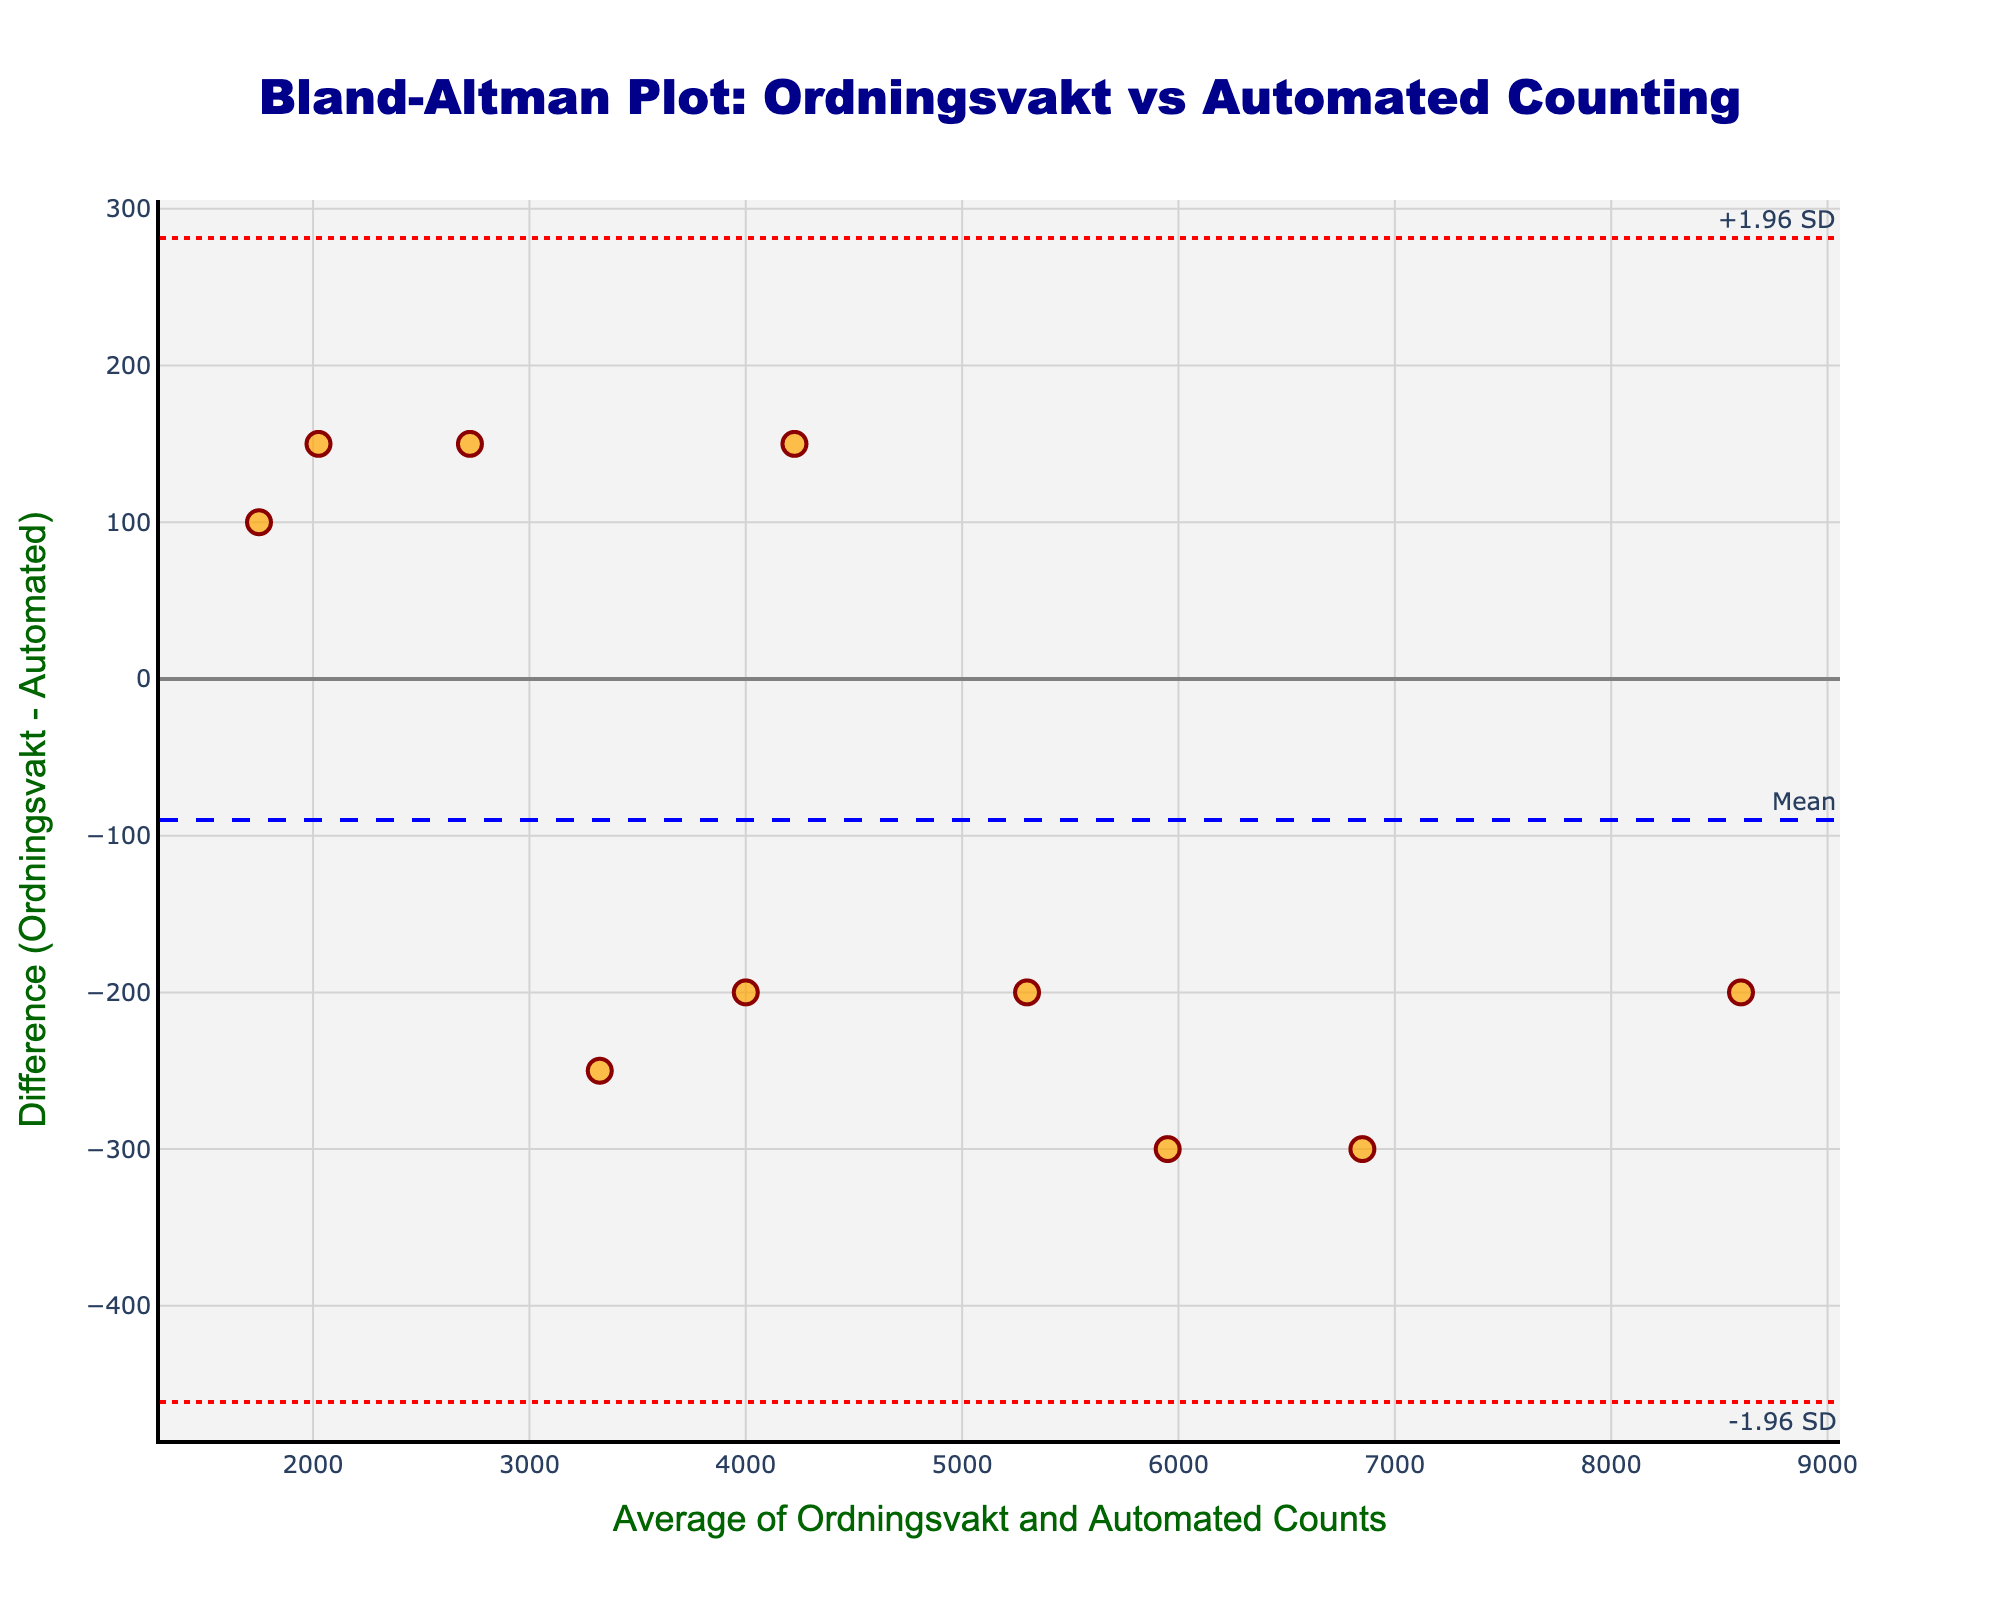How many events are represented in the plot? Count the number of data points (markers) on the scatter plot. Each marker corresponds to one event.
Answer: 10 What is the title of the Bland-Altman plot? The title is displayed at the top of the plot.
Answer: "Bland-Altman Plot: Ordningsvakt vs Automated Counting" What are the colors of the ±1.96 SD lines? The ±1.96 SD lines are annotated with a specific color in the plot.
Answer: Red What's the range of average measurements on the x-axis? The x-axis, labeled "Average of Ordningsvakt and Automated Counts," indicates the range of values between the minimum and maximum points on the x-axis. Estimate these values by looking at the plot.
Answer: 1750 to 8600 Which event has the largest difference between ordningsvakt's estimate and automated count? Identify the highest or lowest point on the y-axis and refer to the event associated with that point using hover information.
Answer: Cityfestivalen What is the mean difference displayed by the blue dashed line? The blue dashed line represents the mean difference. Its value is often displayed or it can be inferred where it intersects the y-axis.
Answer: -100 How many events have a positive difference (ordningsvakt's estimates lower than automated counts)? Count the number of points above the zero line on the y-axis (positive differences).
Answer: 4 Which event has the lowest combined ordningsvakt and automated count? Check the leftmost point on the x-axis, which has the smallest average measurement.
Answer: Vasteras Film Festival Are there more points above or below the mean difference line? Visually compare the number of data points above and below the blue dashed line.
Answer: Below What is the approximate distance between the mean difference and the +1.96 SD line? The vertical distance from the mean difference line to the +1.96 SD line. This can be calculated by subtracting the mean difference from +1.96 times the standard deviation (visually estimate if not provided).
Answer: Approximately 384 